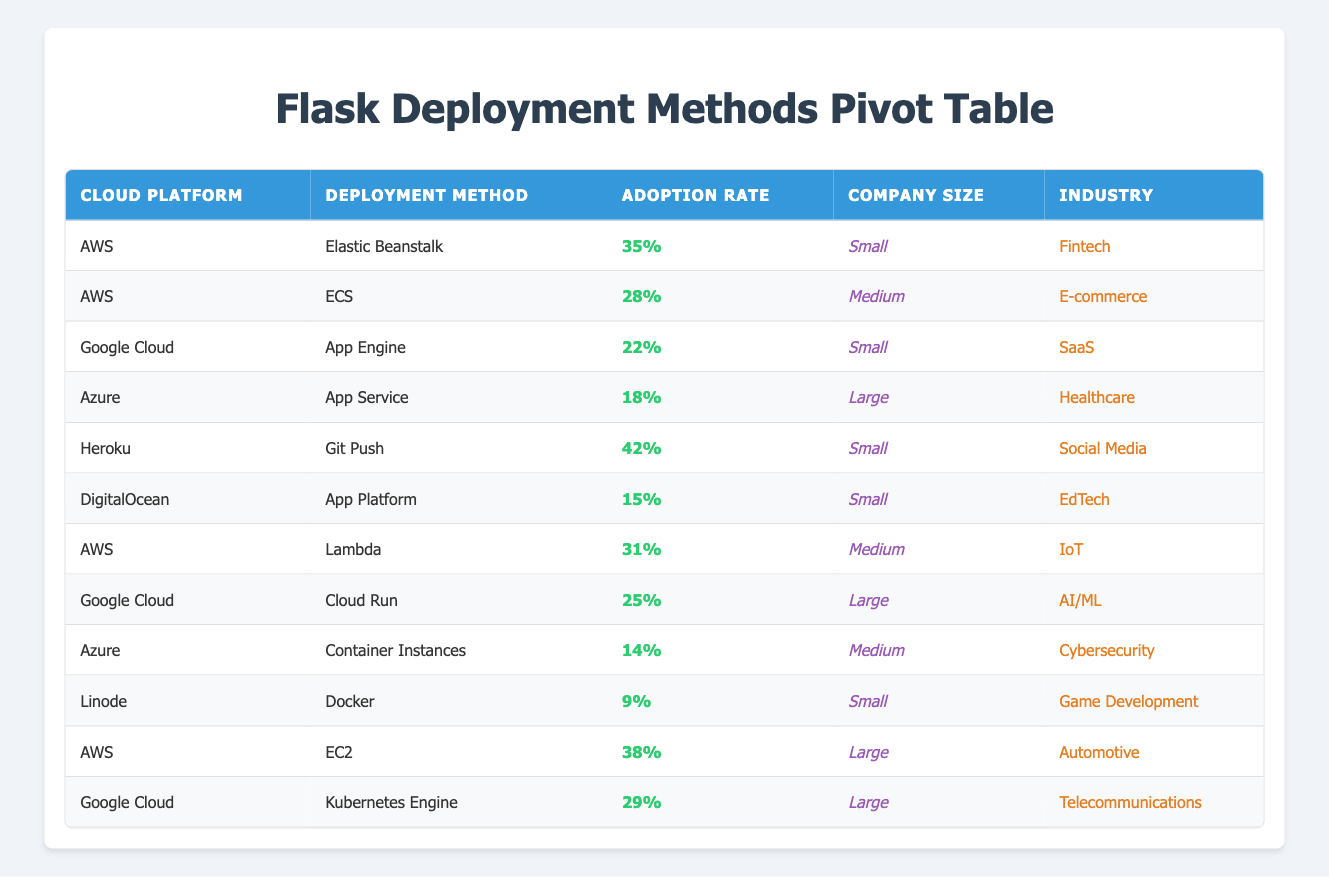What is the highest adoption rate recorded in the table? The table shows various adoption rates for different deployment methods. Scanning through the adoption rates, we find that the highest value is 42% associated with the deployment method "Git Push" on the "Heroku" cloud platform.
Answer: 42% Which cloud platform has the lowest adoption rate for deployment methods in this table? Looking through the table, the lowest adoption rate listed is 9% for the "Docker" deployment method on the "Linode" cloud platform.
Answer: 9% What is the adoption rate for AWS's EC2 deployment method? Referring to the table, the row for "EC2" under the AWS cloud platform shows an adoption rate of 38%.
Answer: 38% Is the adoption rate for Google's App Engine greater than that for Azure's App Service? Checking the table, Google's App Engine has an adoption rate of 22%, while Azure's App Service has an adoption rate of 18%. Since 22% is greater than 18%, the statement is true.
Answer: Yes How many deployment methods have an adoption rate of 25% or higher? By examining the table, we identify the following deployment methods with an adoption rate of 25% or higher: "Git Push" (42%), "Elastic Beanstalk" (35%), "EC2" (38%), "Lambda" (31%), "Kubernetes Engine" (29%), "Cloud Run" (25%), and "ECS" (28%). Counting these, there are 7 methods.
Answer: 7 What is the average adoption rate for all deployment methods listed under the Google Cloud platform? The Google Cloud platform has three deployment methods: "App Engine" (22%), "Cloud Run" (25%), and "Kubernetes Engine" (29%). To find the average, we calculate (22 + 25 + 29) = 76, then divide by 3, which results in an average of 25.33%.
Answer: 25.33% Which industry has the highest adoption rate and what is that rate? Scanning the table, we see each industry listed with their corresponding adoption rates. The highest adoption rate of 42% is in the "Social Media" industry associated with the "Git Push" method on "Heroku."
Answer: 42% How many deployment methods are used by Medium-sized companies with adoption rates above 25%? The table shows the following deployment methods for Medium-sized companies: "ECS" (28%) and "Lambda" (31%). Both of these methods have adoption rates above 25%, totaling 2 methods in this category.
Answer: 2 Is the adoption rate for "Elastic Beanstalk" higher than that of "App Service"? According to the table, "Elastic Beanstalk" has an adoption rate of 35%, while "App Service" has an adoption rate of 18%. Since 35% is higher than 18%, the statement is true.
Answer: Yes 